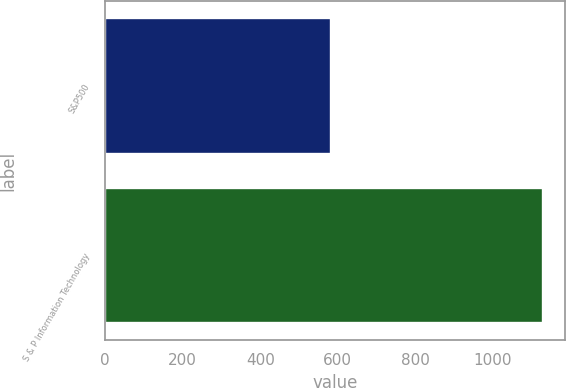<chart> <loc_0><loc_0><loc_500><loc_500><bar_chart><fcel>S&P500<fcel>S & P Information Technology<nl><fcel>582.6<fcel>1128.76<nl></chart> 